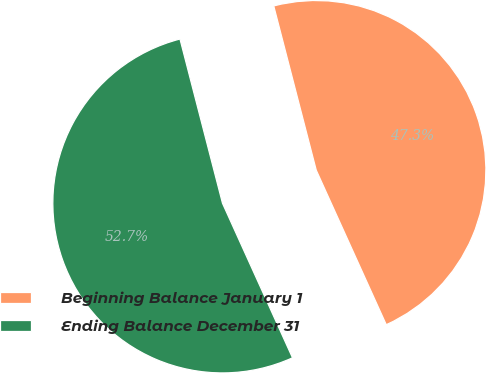<chart> <loc_0><loc_0><loc_500><loc_500><pie_chart><fcel>Beginning Balance January 1<fcel>Ending Balance December 31<nl><fcel>47.26%<fcel>52.74%<nl></chart> 